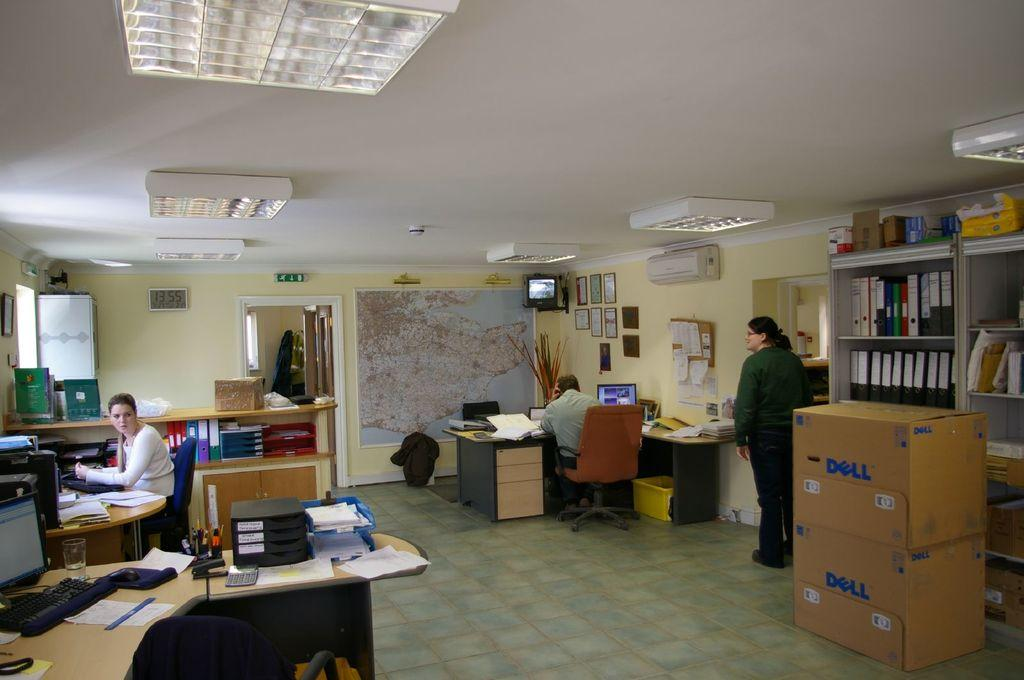How many people are in the image? There are three persons in the image. What are two of the persons doing in the image? Two of the persons are sitting and doing their work. Where is the third person located in the image? One lady person is standing at the right side of the image. What type of key is the giraffe using to unlock the door in the image? There is no giraffe or door present in the image, so it is not possible to answer that question. 